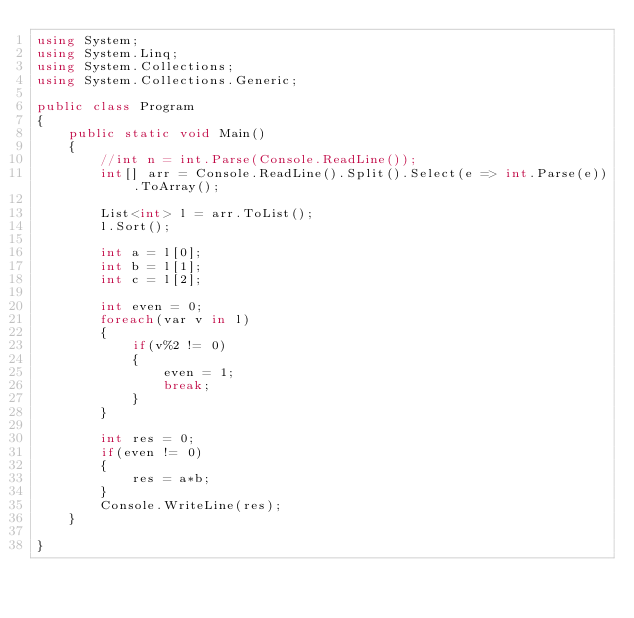Convert code to text. <code><loc_0><loc_0><loc_500><loc_500><_C#_>using System;
using System.Linq;
using System.Collections;
using System.Collections.Generic;
					
public class Program
{
	public static void Main()
	{
		//int n = int.Parse(Console.ReadLine());
		int[] arr = Console.ReadLine().Split().Select(e => int.Parse(e)).ToArray();
		
		List<int> l = arr.ToList();
		l.Sort();
		
		int a = l[0];
		int b = l[1];
		int c = l[2];
		
		int even = 0;
		foreach(var v in l)
		{
			if(v%2 != 0)
			{
				even = 1;
				break;
			}
		}
		
		int res = 0;
		if(even != 0)
		{
			res = a*b;
		}
		Console.WriteLine(res);
	}
	
}</code> 